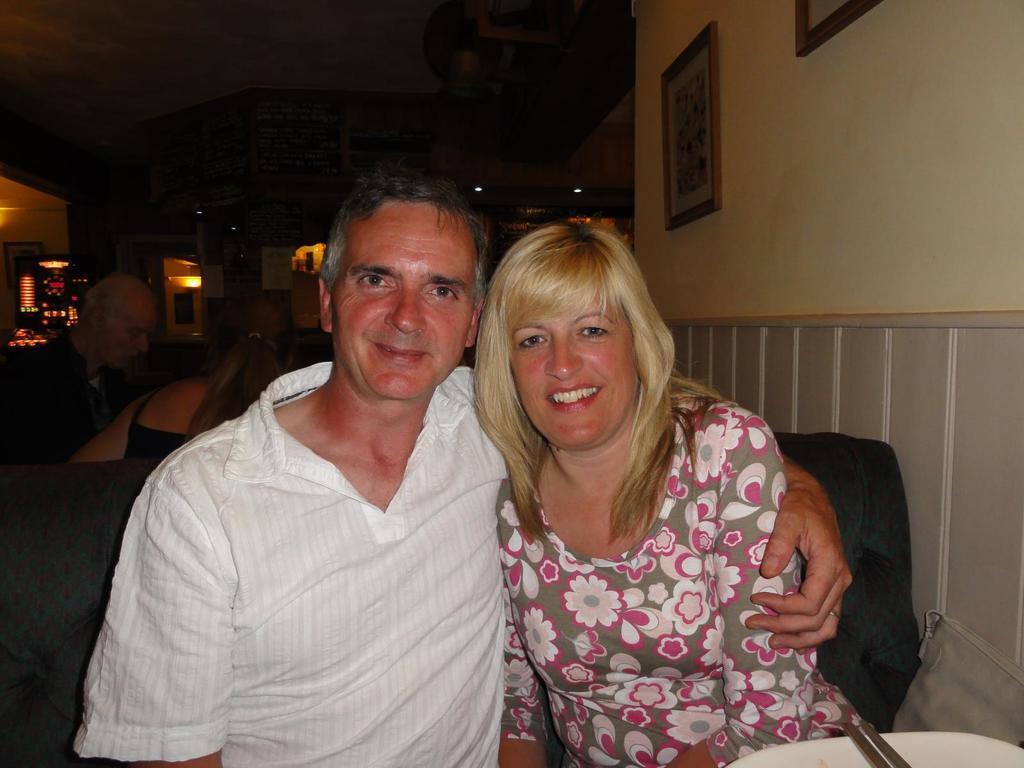Please provide a concise description of this image. In this image in the front there are persons sitting and smiling. In the background there a persons sitting and there are lights. On the right side there are frames on the wall. 